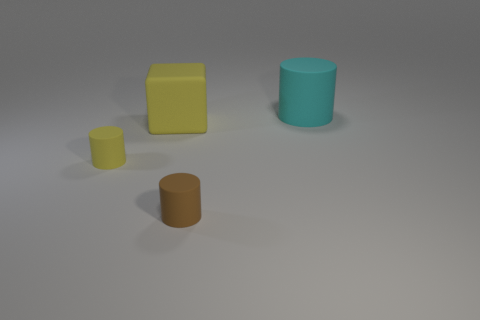The other tiny object that is the same shape as the brown rubber thing is what color?
Keep it short and to the point. Yellow. Is the number of large cylinders on the left side of the yellow block the same as the number of big red matte spheres?
Give a very brief answer. Yes. What number of cylinders are small brown matte objects or yellow things?
Offer a very short reply. 2. What is the color of the large cylinder that is made of the same material as the brown object?
Keep it short and to the point. Cyan. Is the material of the yellow cube the same as the yellow cylinder that is on the left side of the cube?
Your answer should be compact. Yes. What number of objects are either small blue matte spheres or brown cylinders?
Keep it short and to the point. 1. What is the material of the cylinder that is the same color as the cube?
Provide a succinct answer. Rubber. Is there another big cyan rubber object that has the same shape as the big cyan thing?
Offer a terse response. No. There is a tiny brown thing; what number of small yellow cylinders are on the right side of it?
Provide a succinct answer. 0. What is the material of the yellow thing that is left of the large thing that is to the left of the cyan rubber thing?
Your response must be concise. Rubber. 